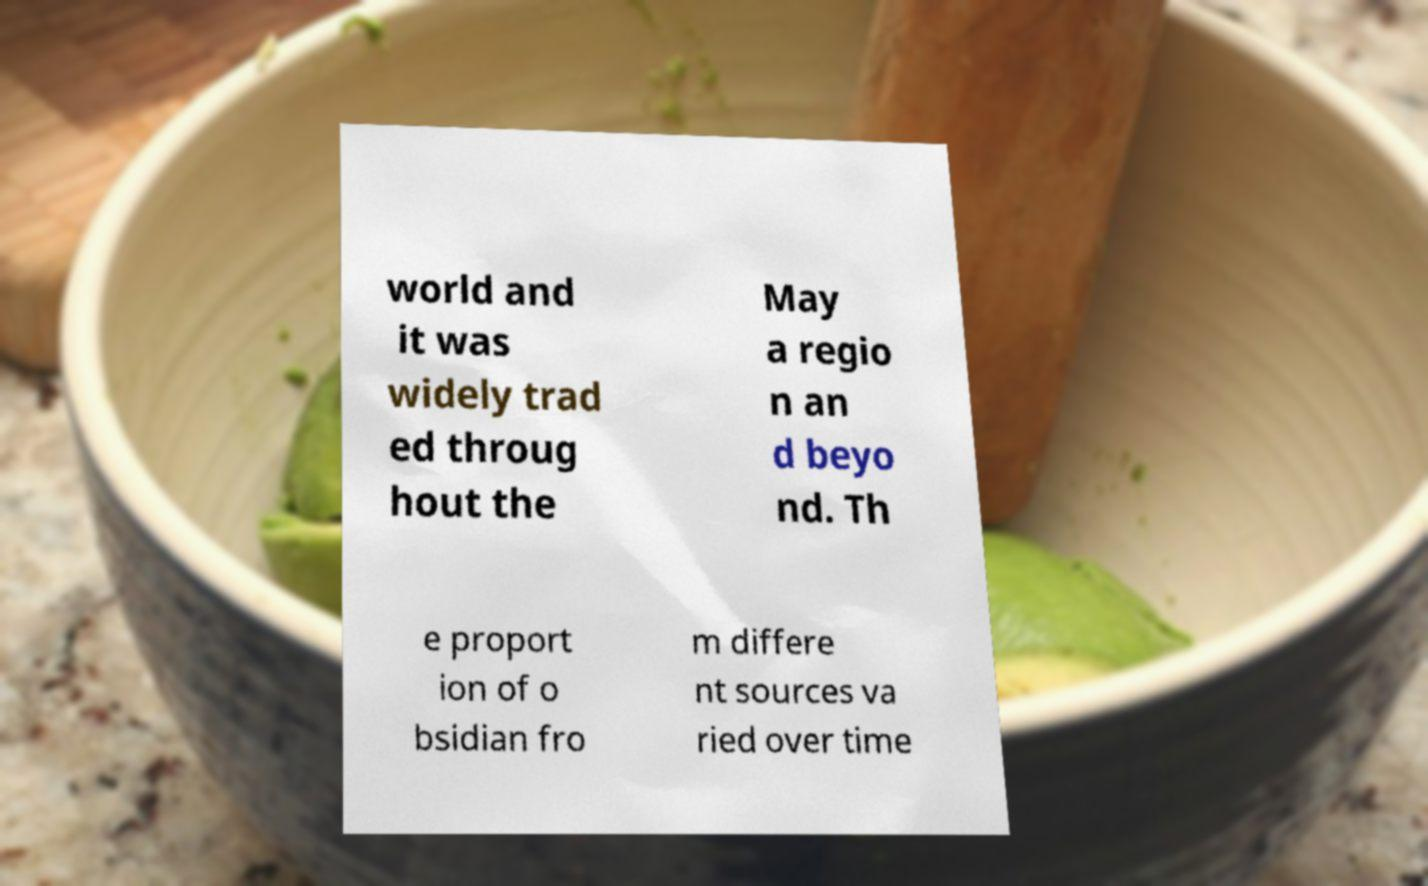Could you assist in decoding the text presented in this image and type it out clearly? world and it was widely trad ed throug hout the May a regio n an d beyo nd. Th e proport ion of o bsidian fro m differe nt sources va ried over time 